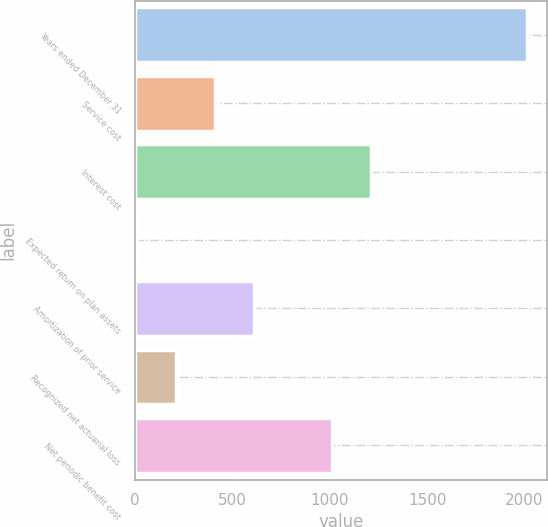Convert chart. <chart><loc_0><loc_0><loc_500><loc_500><bar_chart><fcel>Years ended December 31<fcel>Service cost<fcel>Interest cost<fcel>Expected return on plan assets<fcel>Amortization of prior service<fcel>Recognized net actuarial loss<fcel>Net periodic benefit cost<nl><fcel>2014<fcel>409.2<fcel>1211.6<fcel>8<fcel>609.8<fcel>208.6<fcel>1011<nl></chart> 